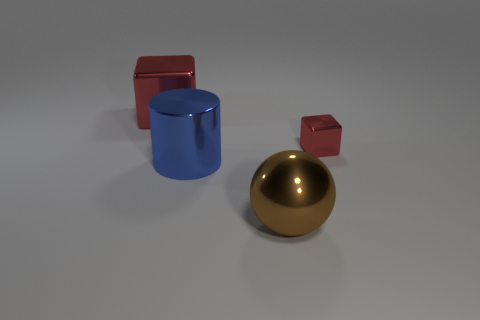How many objects are there in total, and can you describe their shapes and colors? There are four objects in total. Starting from the left, there's a red glossy cube, a blue matte cylinder, a gold reflective sphere, and a small red glossy cube. 